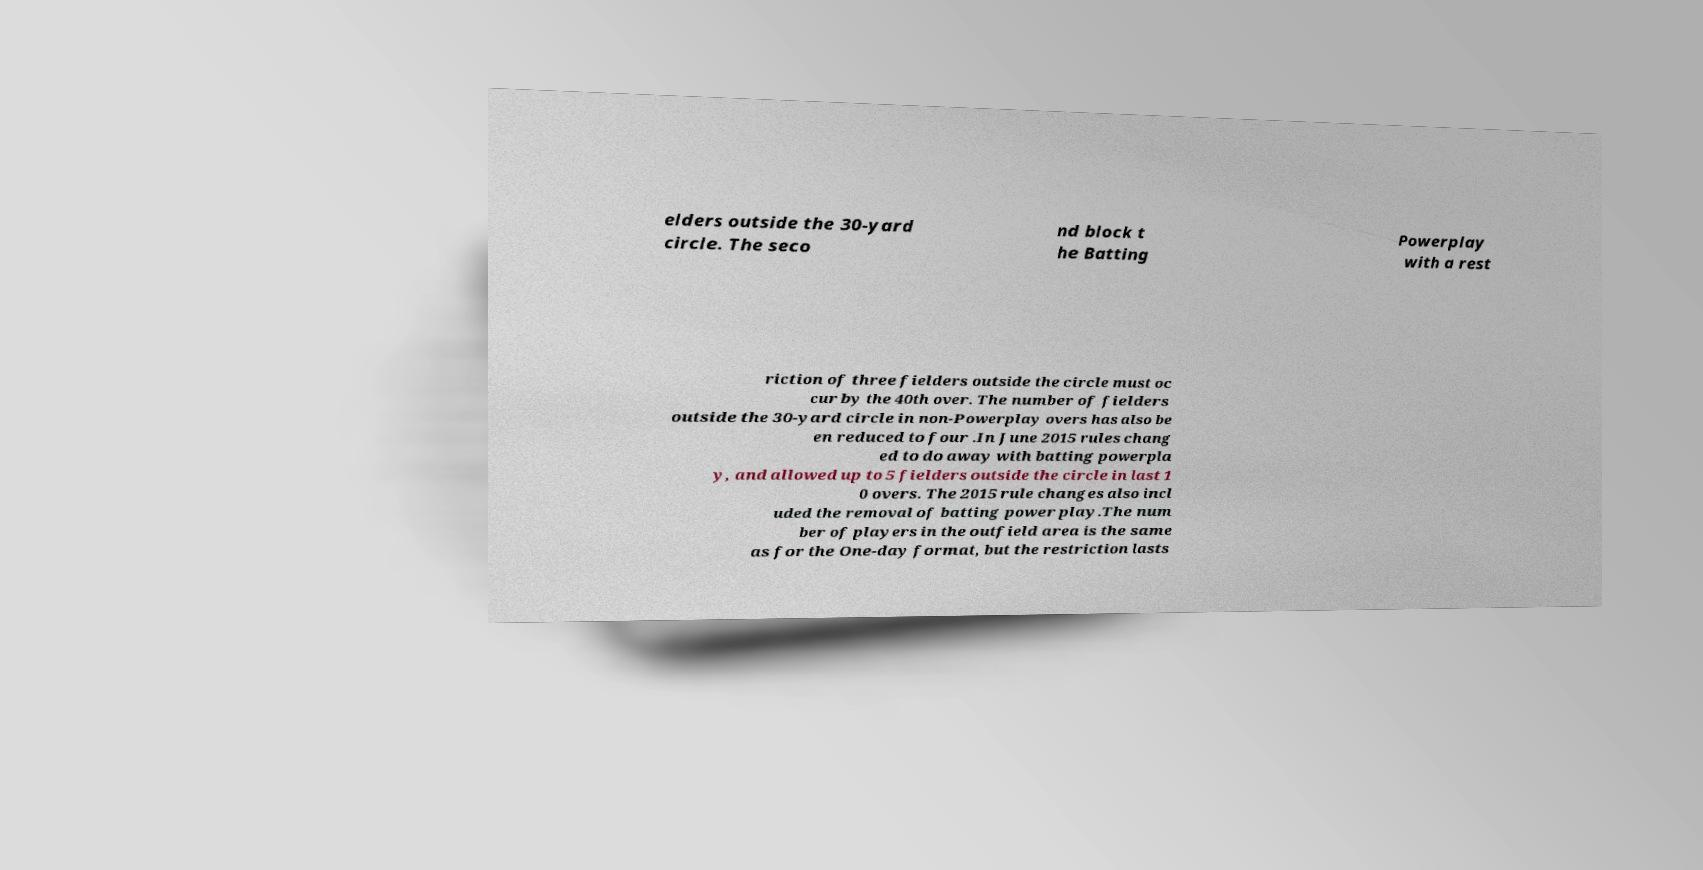What messages or text are displayed in this image? I need them in a readable, typed format. elders outside the 30-yard circle. The seco nd block t he Batting Powerplay with a rest riction of three fielders outside the circle must oc cur by the 40th over. The number of fielders outside the 30-yard circle in non-Powerplay overs has also be en reduced to four .In June 2015 rules chang ed to do away with batting powerpla y, and allowed up to 5 fielders outside the circle in last 1 0 overs. The 2015 rule changes also incl uded the removal of batting power play.The num ber of players in the outfield area is the same as for the One-day format, but the restriction lasts 